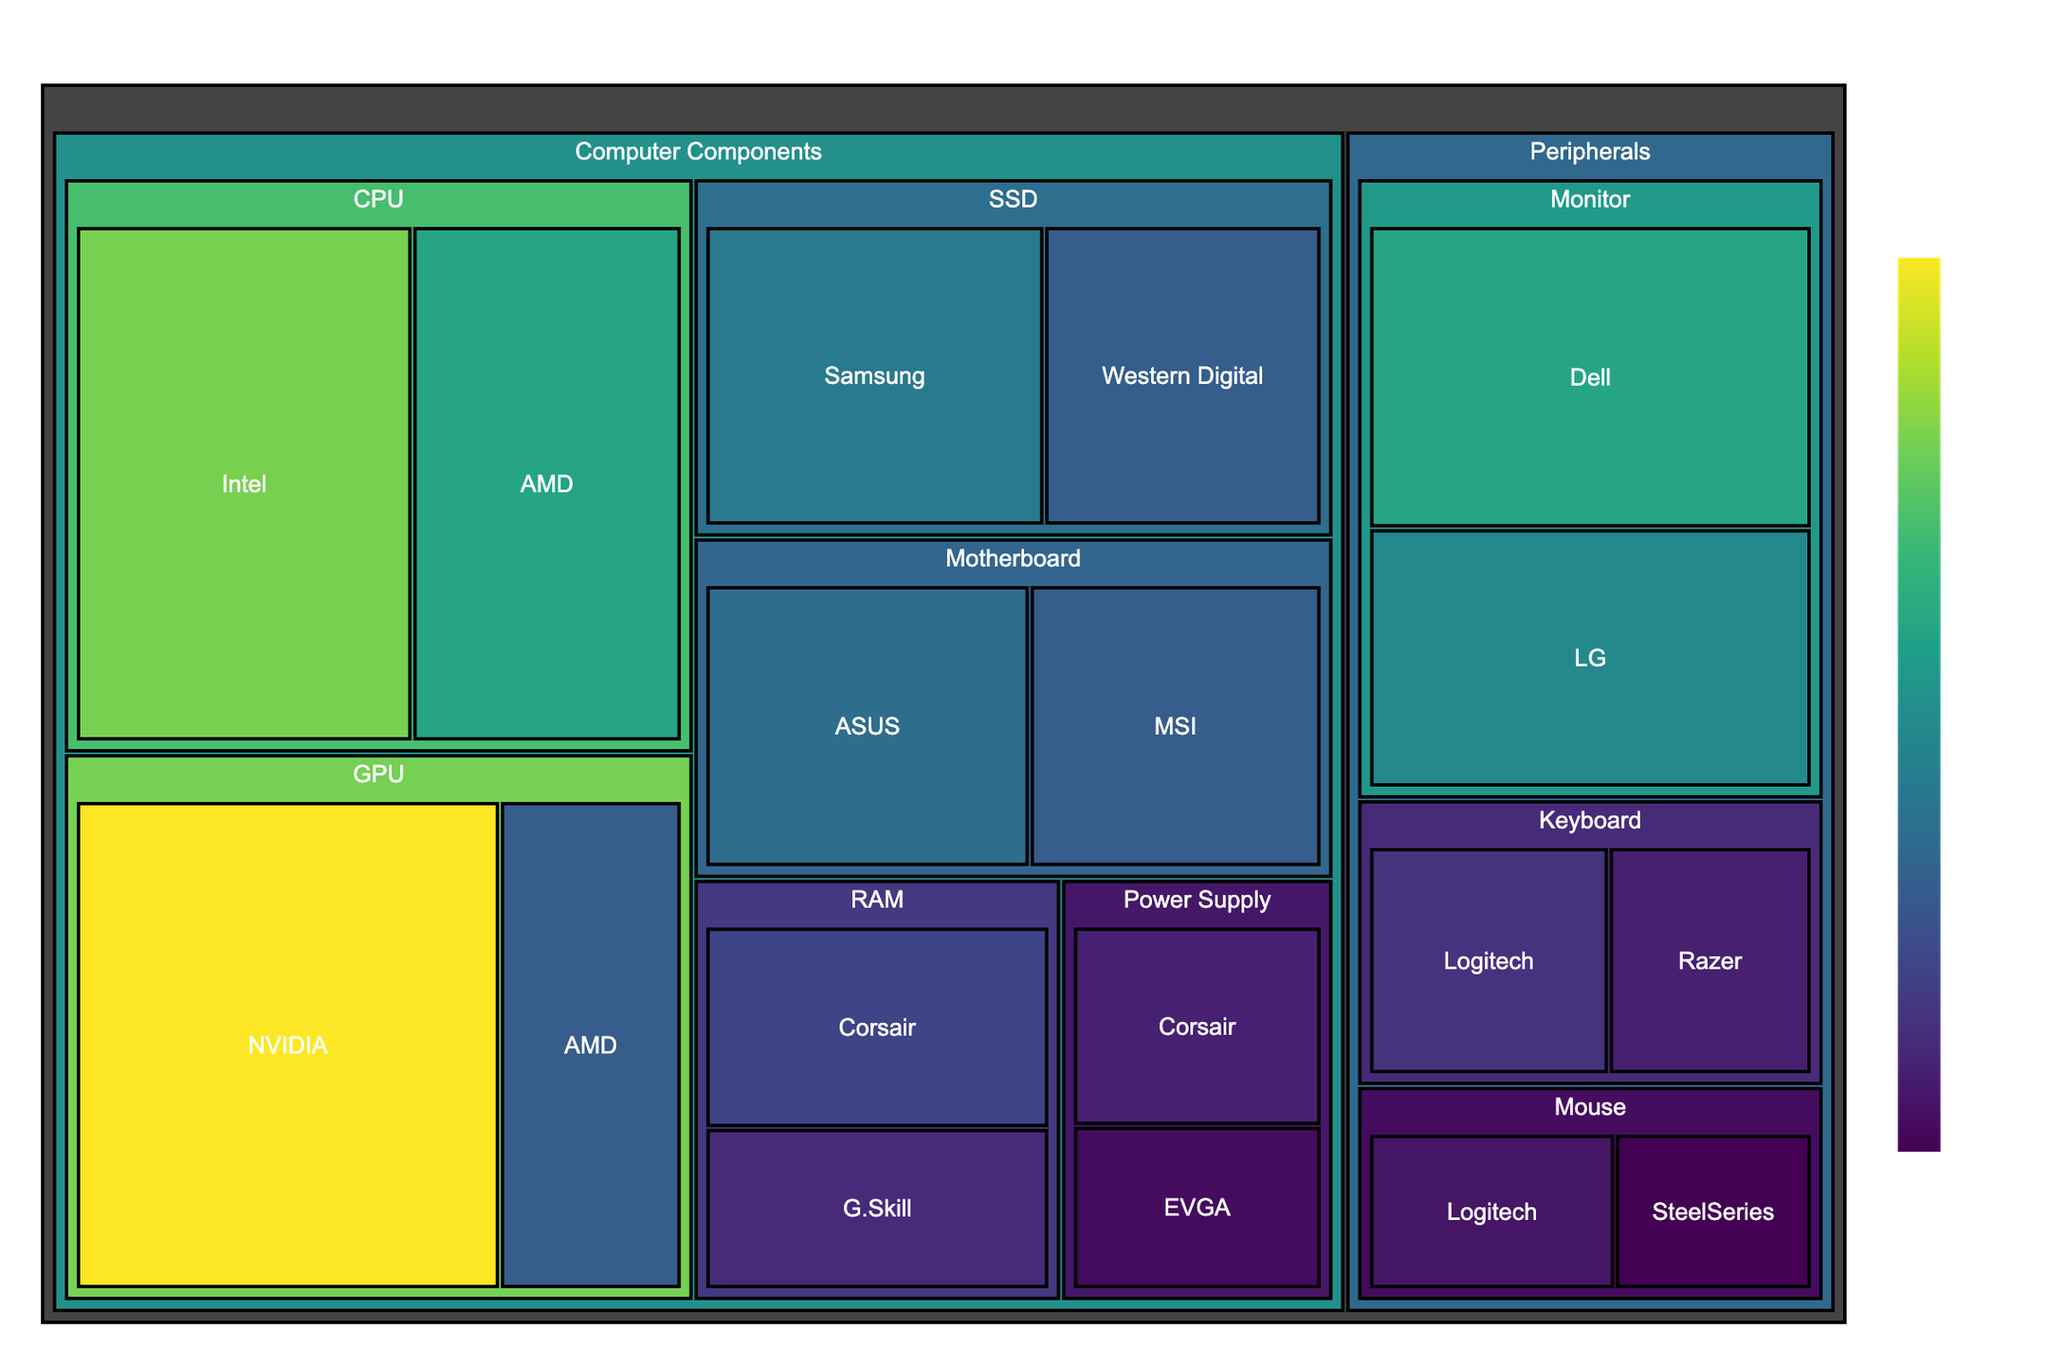What's the title of the figure? The title is usually displayed at the top of the figure and summarizes what the figure is about. In this case, it likely mentions the subject of the Treemap.
Answer: Computer Hardware Sales Distribution Which subcategory within Computer Components has the highest sales? Examine the Treemap's area sizes and values. The largest area with the highest numerical value within the Computer Components category corresponds to the subcategory with the highest sales.
Answer: GPU Which brand has the highest total sales in the Peripherals category? Look at the brands within each subcategory in the Peripherals category. The brand with the largest combined area across its subcategories within Peripherals has the highest total sales.
Answer: Dell How much more did Intel's CPUs sell compared to AMD's CPUs? Find the sales for Intel and AMD in the CPU subcategory. Subtract AMD's sales from Intel's sales. Intel's CPU sales are $350 and AMD's are $280.
Answer: 70 What is the total sales for RAM across all brands? Find the sales values for Corsair and G.Skill within the RAM subcategory and sum them up. Corsair's sales are $150 and G.Skill's are $120.
Answer: 270 Which subcategory within Peripherals has the lowest sales? Identify the subcategory in Peripherals with the smallest combined area and sales value across its brands.
Answer: Mouse Which has higher sales: CPUs by AMD or Monitors by LG? Compare the sales figures for AMD's CPUs and LG's Monitors. AMD CPUs have $280, and LG Monitors have $240.
Answer: AMD CPUs What is the total sales for the GPUs by both NVIDIA and AMD? Add the sales values of NVIDIA and AMD in the GPU subcategory. NVIDIA's sales are $420 and AMD's are $180.
Answer: 600 Compare the sales of SSDs between Samsung and Western Digital. Which one sold more? Examine the sizes of the SSD areas within the Treemap for both brands. Samsung has higher sales compared to Western Digital. Samsung's sales are $220, while Western Digital's are $180.
Answer: Samsung Among keyboards, which brand has higher sales and by how much? Compare the sales values for Logitech and Razer in the Keyboard subcategory. Calculate the difference. Logitech's sales are $130 and Razer's are $110.
Answer: Logitech, 20 